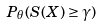<formula> <loc_0><loc_0><loc_500><loc_500>P _ { \theta } ( S ( X ) \geq \gamma )</formula> 